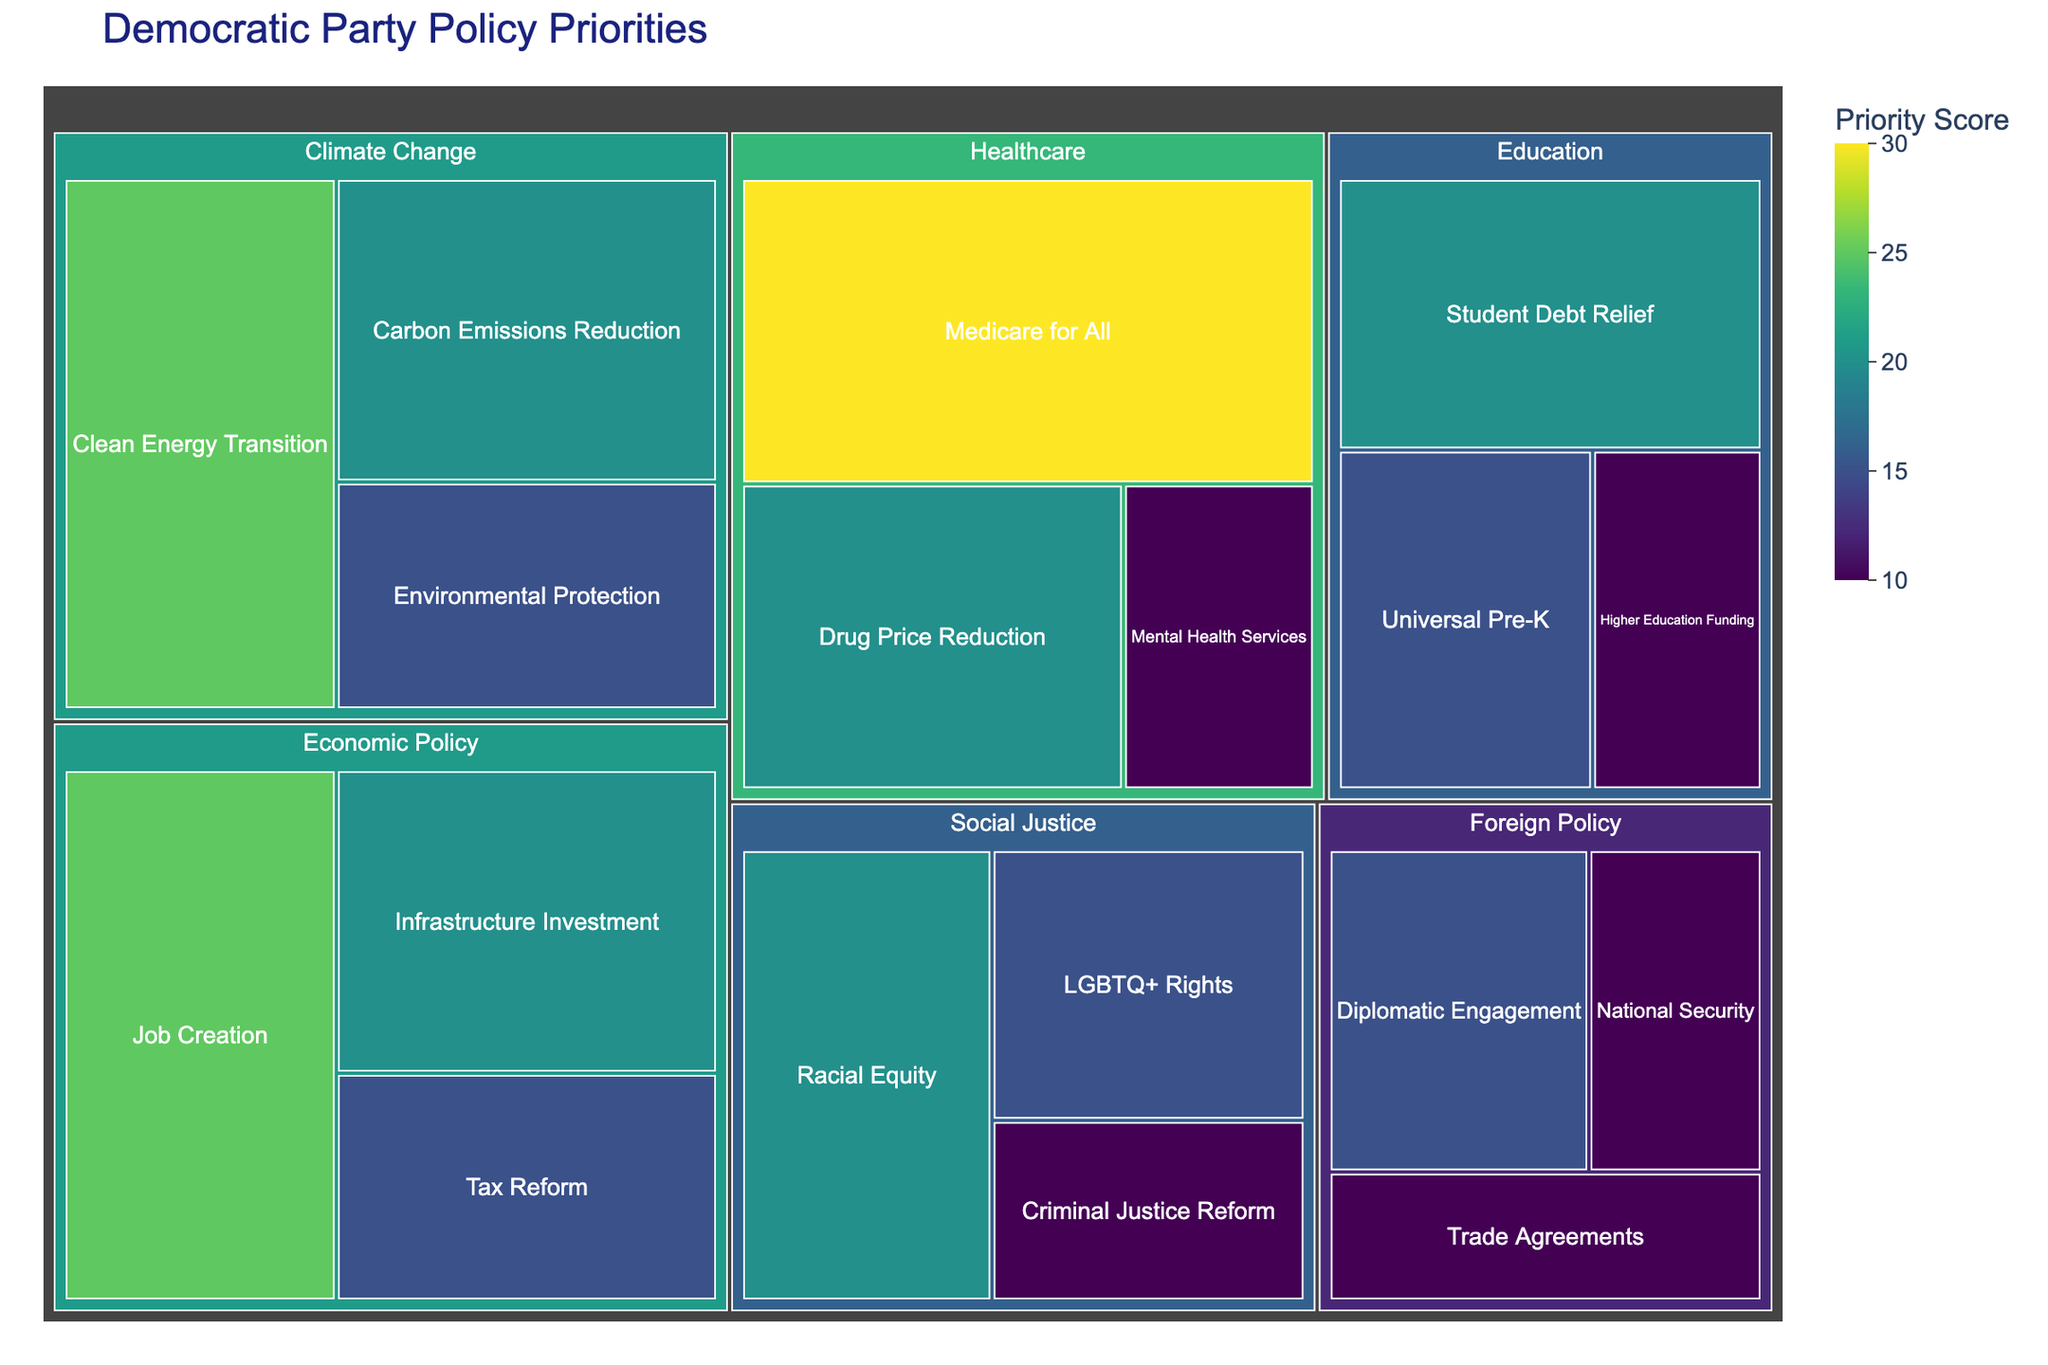What is the highest priority score among all policy initiatives? The highest score can be found by looking at the value associated with each rectangle in the treemap. The highest value is 30, which is for "Medicare for All" under the "Healthcare" area.
Answer: 30 Which policy area has the most initiatives listed? To find this, we count the number of sub-areas under each main area. "Economic Policy" and "Healthcare" both have three initiatives listed.
Answer: Economic Policy, Healthcare Compare the total priority score of "Climate Change" and "Social Justice" areas. Which one is higher? To compare, sum up the values of the initiatives under each area. "Climate Change": 25+20+15=60 and "Social Justice": 20+15+10=45. "Climate Change" has a higher total.
Answer: Climate Change What is the average priority score of the initiatives under "Education"? To find the average, add up the values for "Education" and divide by the number of initiatives. (20+15+10)/3 = 15
Answer: 15 How many initiatives have a priority score greater than 15? Count the rectangles with values greater than 15. The initiatives are "Job Creation", "Medicare for All", "Drug Price Reduction", "Clean Energy Transition", "Carbon Emissions Reduction", "Racial Equity", and "Student Debt Relief". There are 7 initiatives.
Answer: 7 Identify the sub-area with the lowest priority score in the "Foreign Policy" area. Look at the rectangles within "Foreign Policy" and find the one with the lowest value. The sub-area with the lowest score is "National Security" with a value of 10.
Answer: National Security What is the combined priority score for all initiatives under "Economic Policy" and "Healthcare"? Add up the values for both "Economic Policy" and "Healthcare". Economic Policy: 25+20+15=60, Healthcare: 30+20+10=60. Combined score is 60+60=120.
Answer: 120 Which sub-area in "Economic Policy" has a higher priority score than "Universal Pre-K" in "Education"? Compare the values within "Economic Policy" with the value of "Universal Pre-K" (which is 15). "Job Creation" (25) and "Infrastructure Investment" (20) both have higher scores.
Answer: Job Creation, Infrastructure Investment How does the visual color intensity relate to the priority scores? In the treemap, the color intensity indicates the value of the priority score. Darker colors represent higher values while lighter colors represent lower values.
Answer: Darker colors mean higher scores 